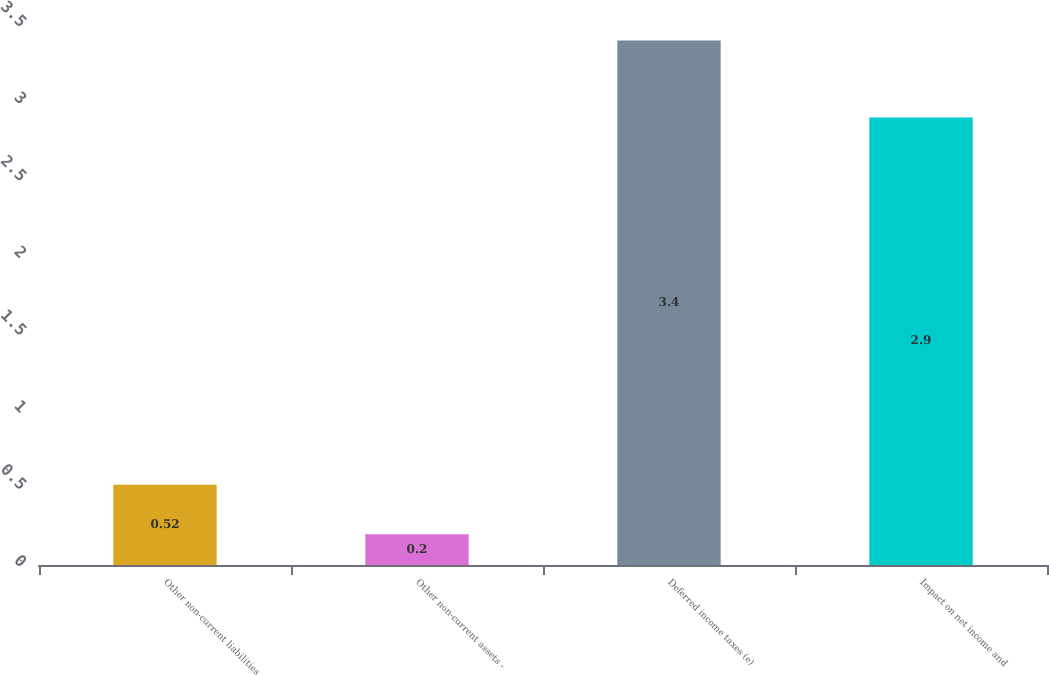<chart> <loc_0><loc_0><loc_500><loc_500><bar_chart><fcel>Other non-current liabilities<fcel>Other non-current assets -<fcel>Deferred income taxes (e)<fcel>Impact on net income and<nl><fcel>0.52<fcel>0.2<fcel>3.4<fcel>2.9<nl></chart> 